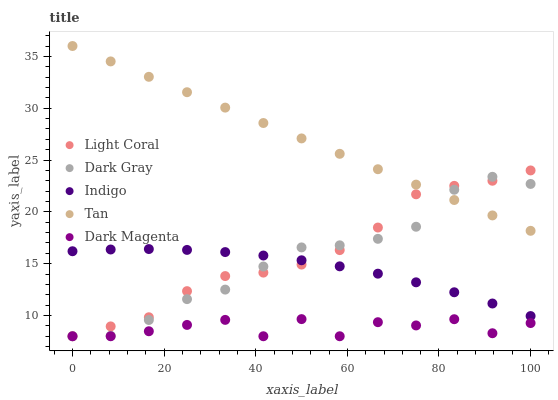Does Dark Magenta have the minimum area under the curve?
Answer yes or no. Yes. Does Tan have the maximum area under the curve?
Answer yes or no. Yes. Does Dark Gray have the minimum area under the curve?
Answer yes or no. No. Does Dark Gray have the maximum area under the curve?
Answer yes or no. No. Is Tan the smoothest?
Answer yes or no. Yes. Is Dark Magenta the roughest?
Answer yes or no. Yes. Is Dark Gray the smoothest?
Answer yes or no. No. Is Dark Gray the roughest?
Answer yes or no. No. Does Light Coral have the lowest value?
Answer yes or no. Yes. Does Tan have the lowest value?
Answer yes or no. No. Does Tan have the highest value?
Answer yes or no. Yes. Does Dark Gray have the highest value?
Answer yes or no. No. Is Dark Magenta less than Tan?
Answer yes or no. Yes. Is Tan greater than Indigo?
Answer yes or no. Yes. Does Dark Magenta intersect Light Coral?
Answer yes or no. Yes. Is Dark Magenta less than Light Coral?
Answer yes or no. No. Is Dark Magenta greater than Light Coral?
Answer yes or no. No. Does Dark Magenta intersect Tan?
Answer yes or no. No. 